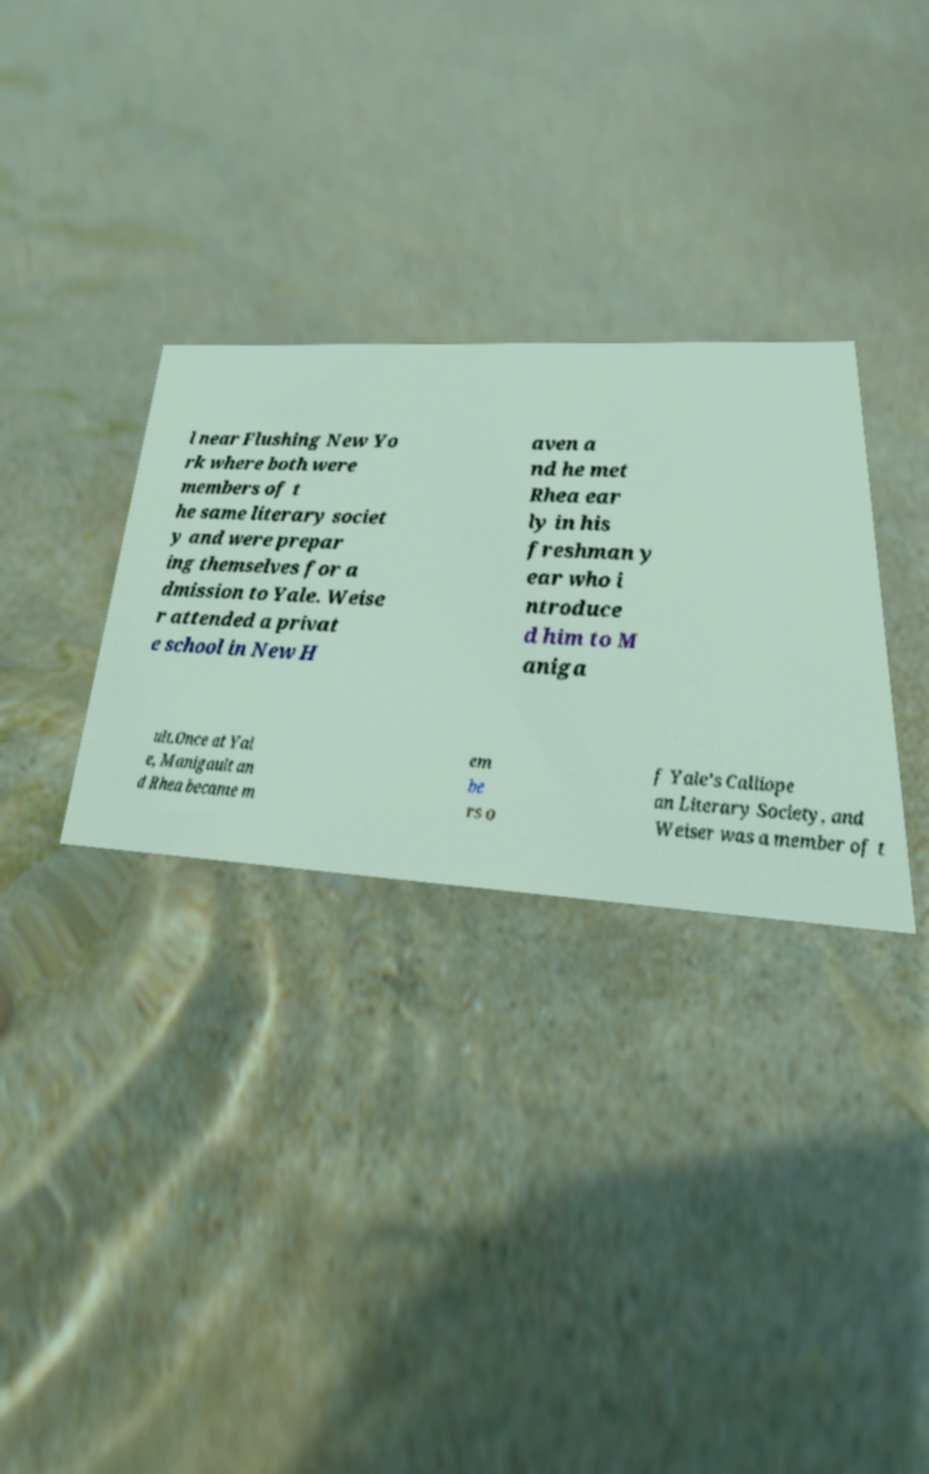For documentation purposes, I need the text within this image transcribed. Could you provide that? l near Flushing New Yo rk where both were members of t he same literary societ y and were prepar ing themselves for a dmission to Yale. Weise r attended a privat e school in New H aven a nd he met Rhea ear ly in his freshman y ear who i ntroduce d him to M aniga ult.Once at Yal e, Manigault an d Rhea became m em be rs o f Yale's Calliope an Literary Society, and Weiser was a member of t 